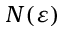<formula> <loc_0><loc_0><loc_500><loc_500>N ( \varepsilon )</formula> 